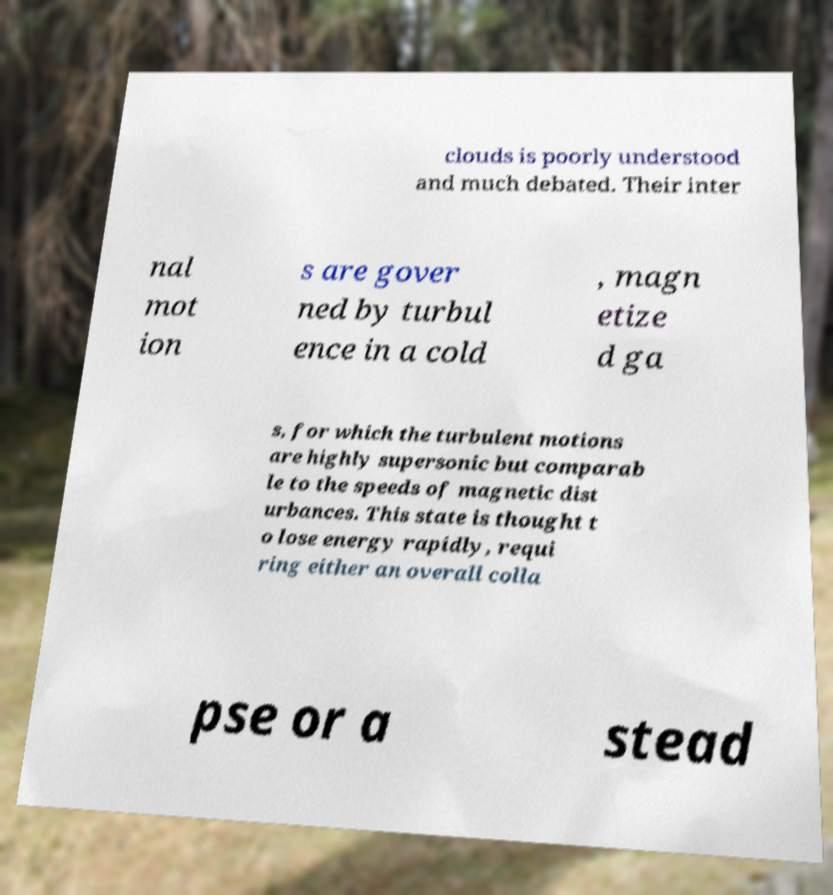I need the written content from this picture converted into text. Can you do that? clouds is poorly understood and much debated. Their inter nal mot ion s are gover ned by turbul ence in a cold , magn etize d ga s, for which the turbulent motions are highly supersonic but comparab le to the speeds of magnetic dist urbances. This state is thought t o lose energy rapidly, requi ring either an overall colla pse or a stead 